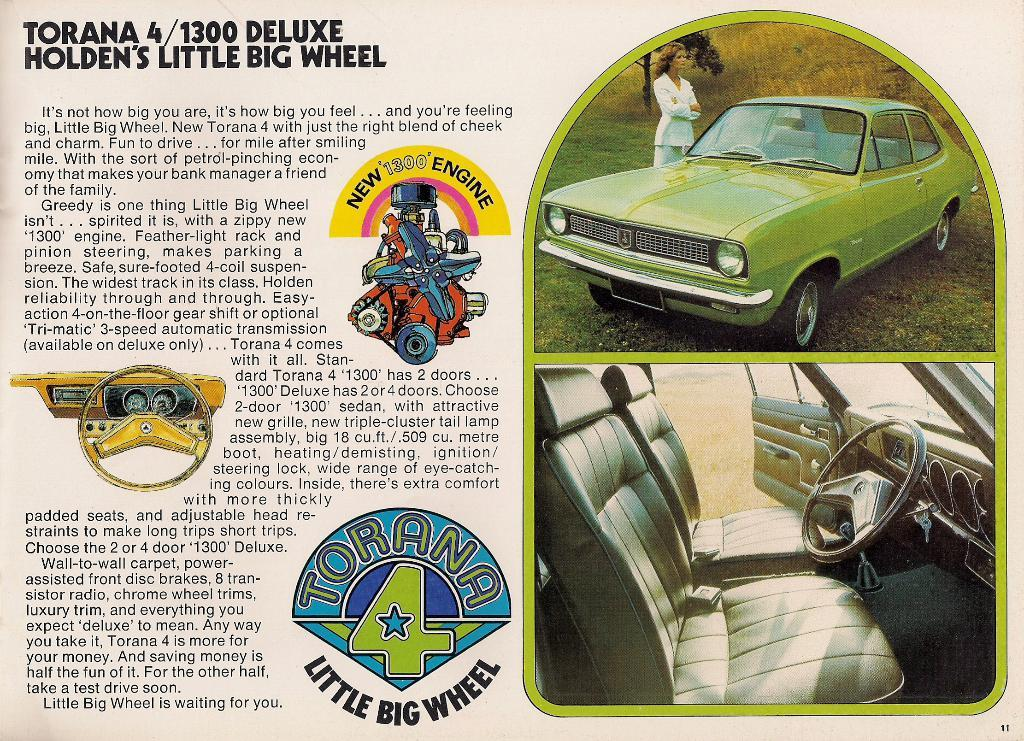What is present in the image that contains text? There is a poster in the image that contains text. What is depicted in the poster? The poster contains text, cars, and a woman. What type of flight is depicted in the poster? There is no flight depicted in the poster; it only contains text, cars, and a woman. Which direction is the scene in the poster facing? The provided facts do not mention any specific direction or scene in the poster. 